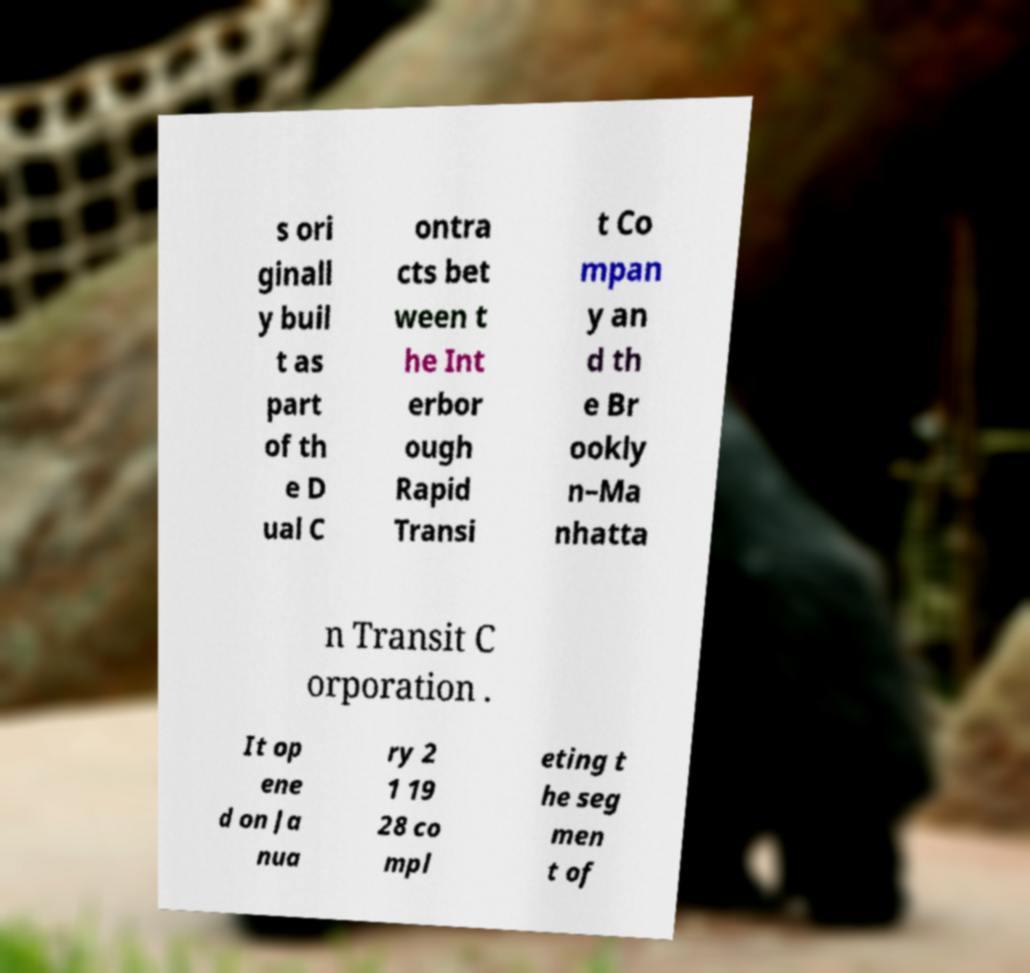There's text embedded in this image that I need extracted. Can you transcribe it verbatim? s ori ginall y buil t as part of th e D ual C ontra cts bet ween t he Int erbor ough Rapid Transi t Co mpan y an d th e Br ookly n–Ma nhatta n Transit C orporation . It op ene d on Ja nua ry 2 1 19 28 co mpl eting t he seg men t of 